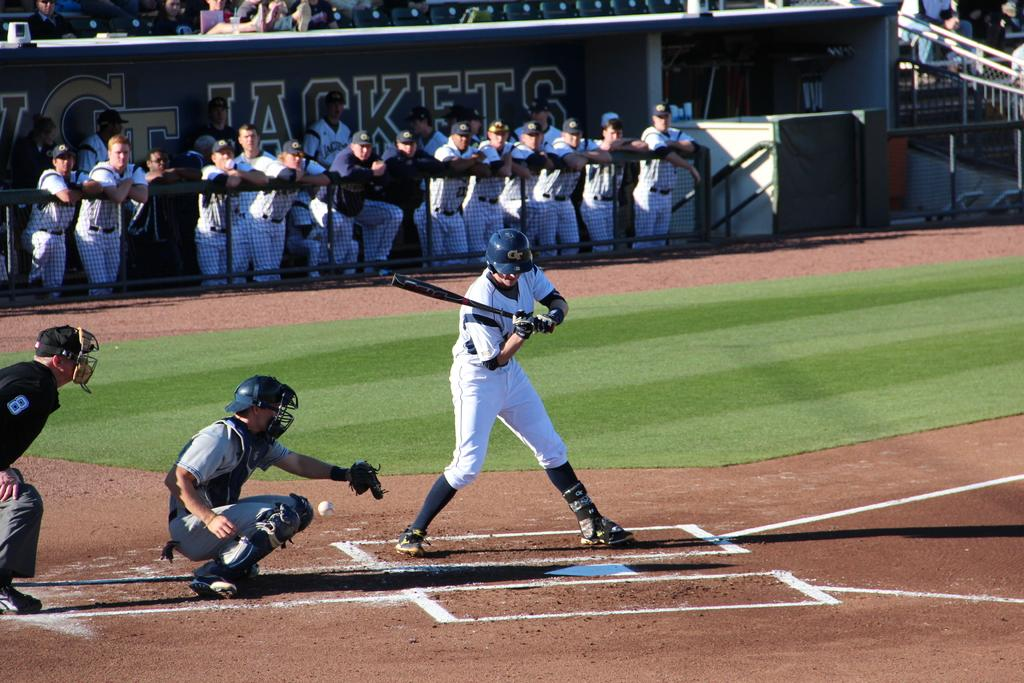<image>
Present a compact description of the photo's key features. The batter from the GT Jackets doesn't offer at the pitch low and inside. 